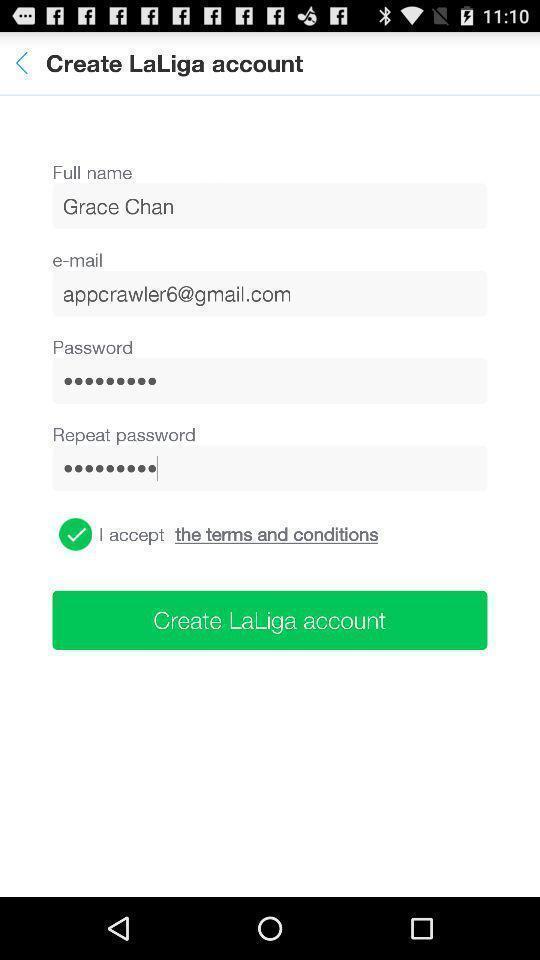Give me a summary of this screen capture. Page the displaying the create account details. 